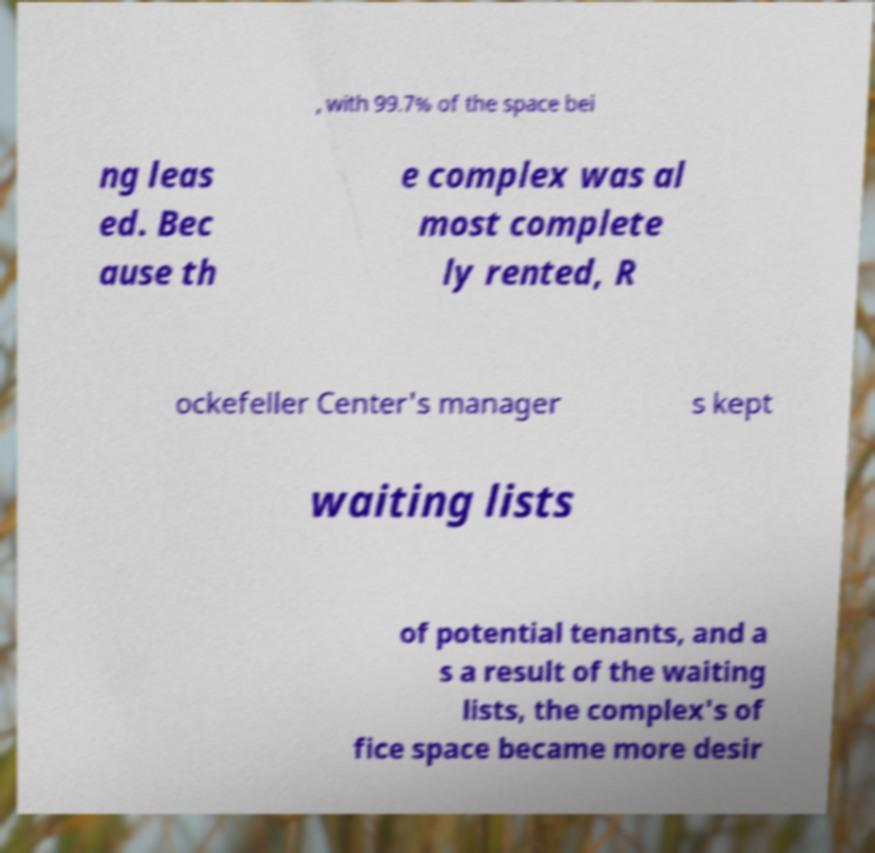Can you accurately transcribe the text from the provided image for me? , with 99.7% of the space bei ng leas ed. Bec ause th e complex was al most complete ly rented, R ockefeller Center's manager s kept waiting lists of potential tenants, and a s a result of the waiting lists, the complex's of fice space became more desir 